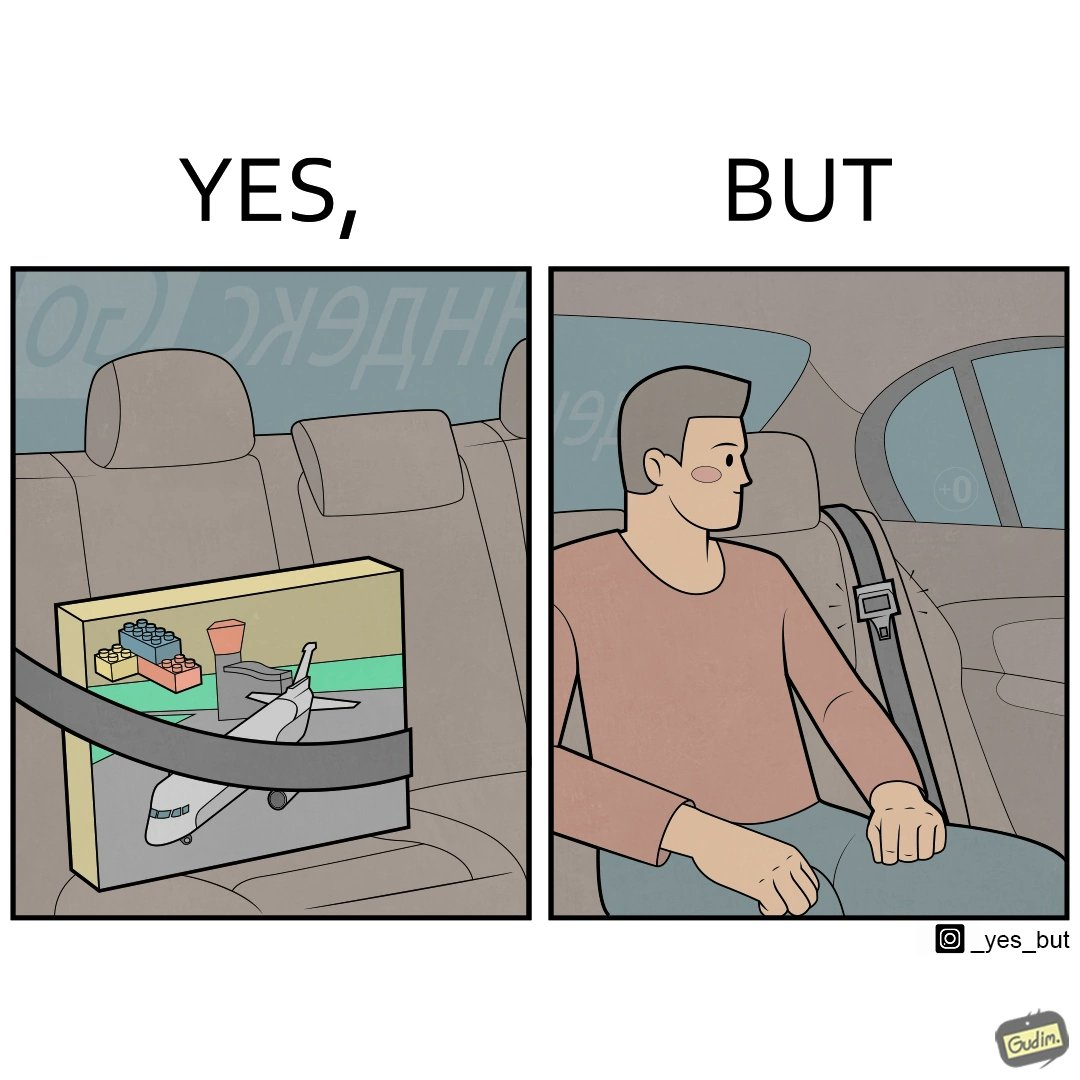What does this image depict? The image is ironical, as an inanimate box of building blocks has been secured by the seatbelt in the backseat of a car, while a person sitting in the backseat is not wearing the seatbelt, while the person would actually need the seatbelt in case there is an accident. 